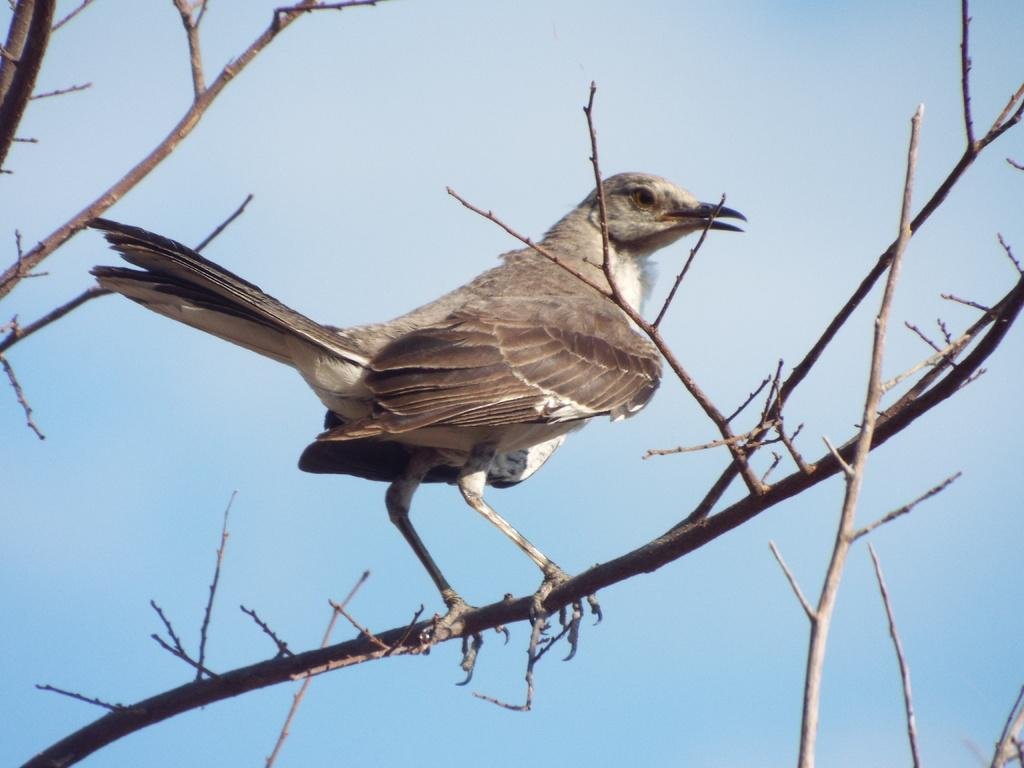What type of animal is in the image? There is a bird in the image. Where is the bird located? The bird is standing on a branch. What can be seen in the background of the image? There is sky visible in the background of the image. What type of mint is growing on the branch next to the bird? There is no mint visible in the image; only the bird and the branch are present. 